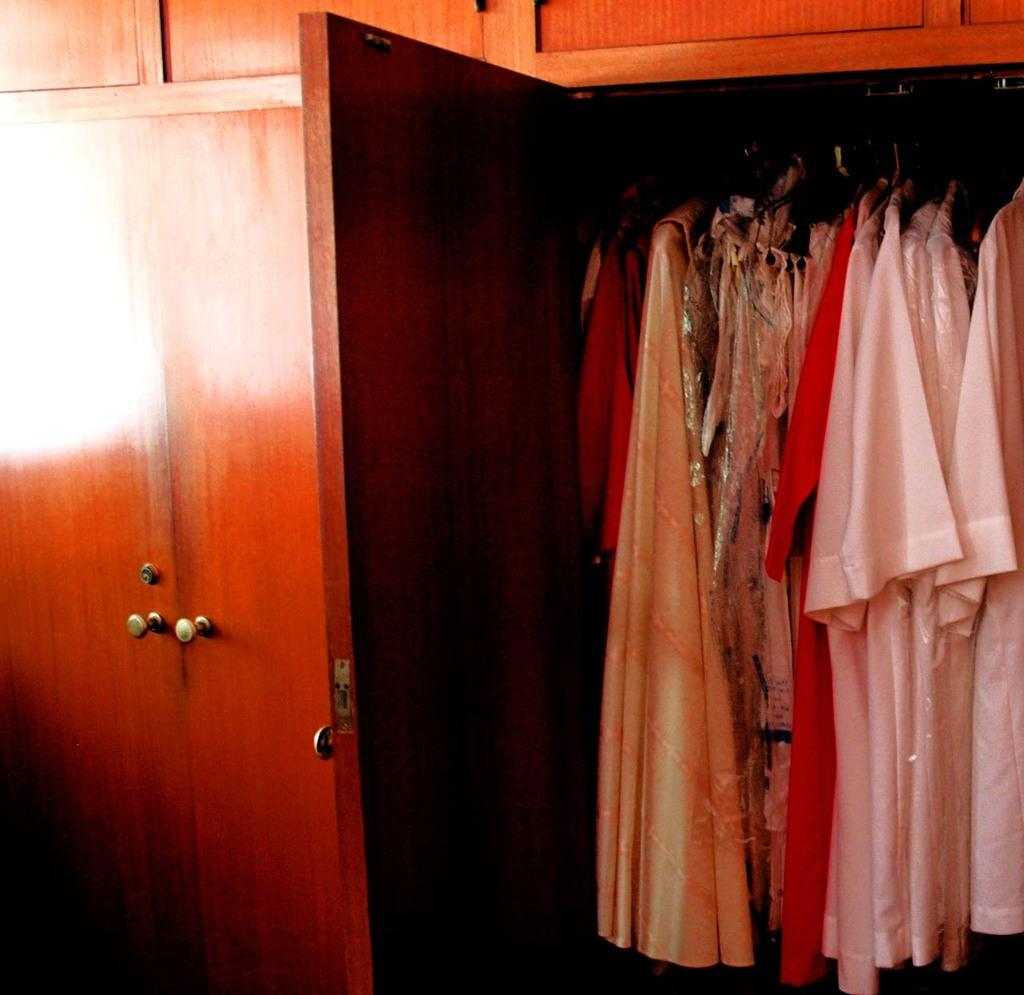What type of furniture is present in the image? There is a cupboard in the image. What is stored inside the cupboard? The cupboard contains dresses. What is the name of the light fixture above the cupboard? There is no light fixture mentioned or visible in the image. 